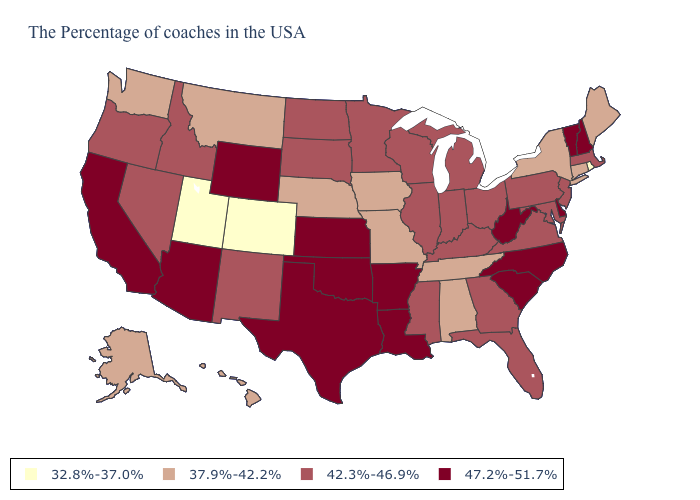Among the states that border Pennsylvania , which have the lowest value?
Keep it brief. New York. Does New Hampshire have the same value as California?
Be succinct. Yes. Which states hav the highest value in the MidWest?
Short answer required. Kansas. Does Colorado have the lowest value in the West?
Answer briefly. Yes. Name the states that have a value in the range 47.2%-51.7%?
Be succinct. New Hampshire, Vermont, Delaware, North Carolina, South Carolina, West Virginia, Louisiana, Arkansas, Kansas, Oklahoma, Texas, Wyoming, Arizona, California. Name the states that have a value in the range 37.9%-42.2%?
Short answer required. Maine, Connecticut, New York, Alabama, Tennessee, Missouri, Iowa, Nebraska, Montana, Washington, Alaska, Hawaii. Does the map have missing data?
Short answer required. No. Which states have the lowest value in the USA?
Keep it brief. Rhode Island, Colorado, Utah. What is the value of Montana?
Keep it brief. 37.9%-42.2%. Among the states that border South Dakota , which have the lowest value?
Keep it brief. Iowa, Nebraska, Montana. Does Utah have the lowest value in the USA?
Write a very short answer. Yes. What is the highest value in states that border Oregon?
Concise answer only. 47.2%-51.7%. What is the value of Idaho?
Write a very short answer. 42.3%-46.9%. Name the states that have a value in the range 47.2%-51.7%?
Quick response, please. New Hampshire, Vermont, Delaware, North Carolina, South Carolina, West Virginia, Louisiana, Arkansas, Kansas, Oklahoma, Texas, Wyoming, Arizona, California. 